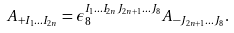<formula> <loc_0><loc_0><loc_500><loc_500>A _ { + I _ { 1 } \dots I _ { 2 n } } = \epsilon _ { 8 } ^ { I _ { 1 } \dots I _ { 2 n } J _ { 2 n + 1 } \dots J _ { 8 } } A _ { - J _ { 2 n + 1 } \dots J _ { 8 } } .</formula> 